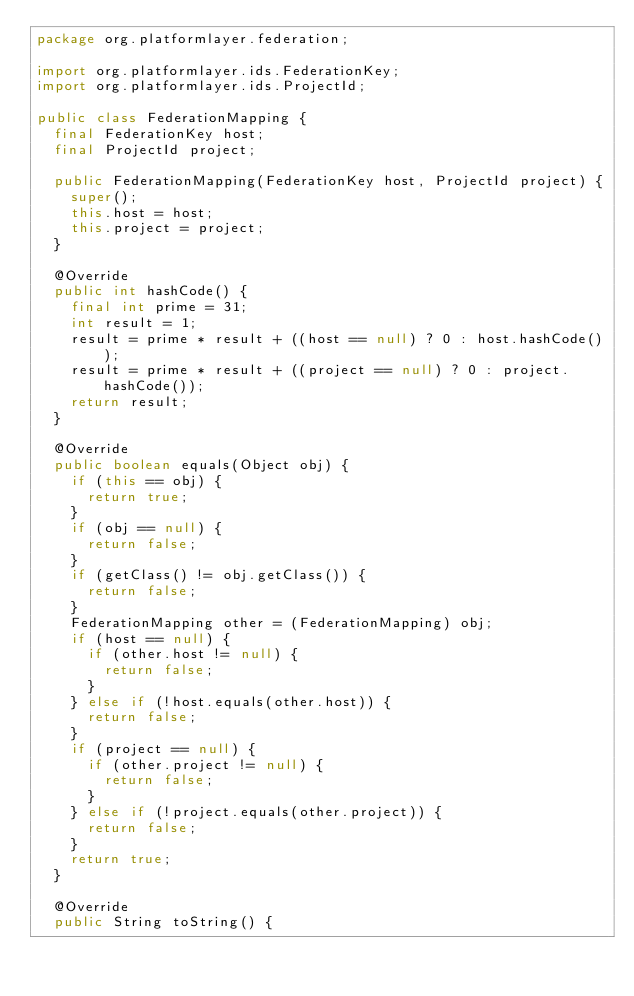Convert code to text. <code><loc_0><loc_0><loc_500><loc_500><_Java_>package org.platformlayer.federation;

import org.platformlayer.ids.FederationKey;
import org.platformlayer.ids.ProjectId;

public class FederationMapping {
	final FederationKey host;
	final ProjectId project;

	public FederationMapping(FederationKey host, ProjectId project) {
		super();
		this.host = host;
		this.project = project;
	}

	@Override
	public int hashCode() {
		final int prime = 31;
		int result = 1;
		result = prime * result + ((host == null) ? 0 : host.hashCode());
		result = prime * result + ((project == null) ? 0 : project.hashCode());
		return result;
	}

	@Override
	public boolean equals(Object obj) {
		if (this == obj) {
			return true;
		}
		if (obj == null) {
			return false;
		}
		if (getClass() != obj.getClass()) {
			return false;
		}
		FederationMapping other = (FederationMapping) obj;
		if (host == null) {
			if (other.host != null) {
				return false;
			}
		} else if (!host.equals(other.host)) {
			return false;
		}
		if (project == null) {
			if (other.project != null) {
				return false;
			}
		} else if (!project.equals(other.project)) {
			return false;
		}
		return true;
	}

	@Override
	public String toString() {</code> 